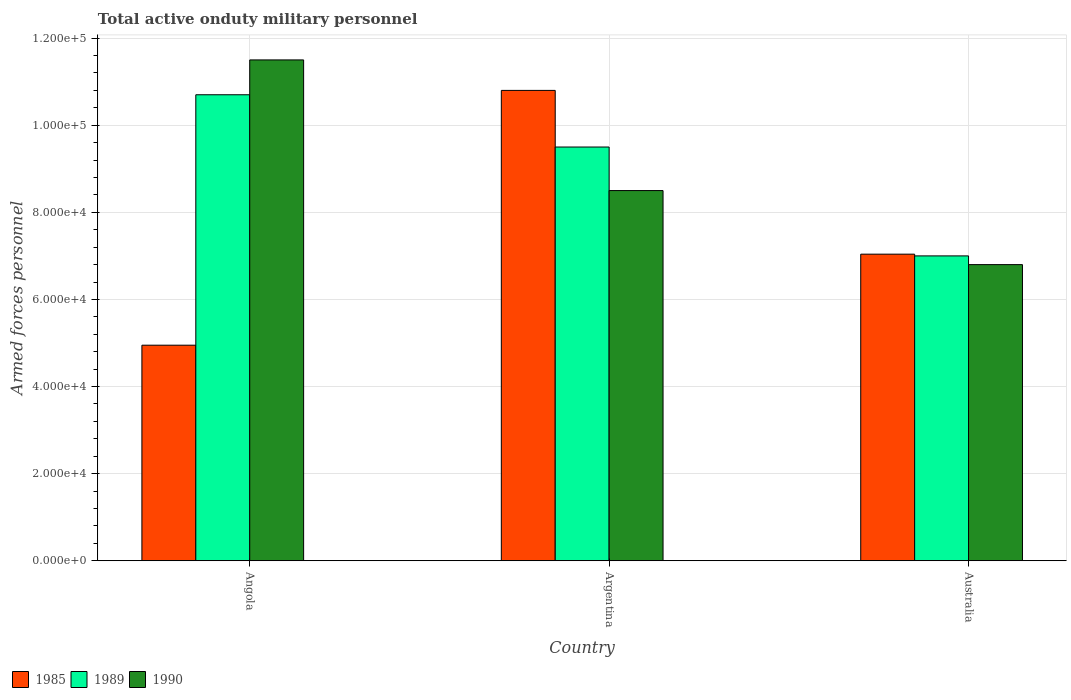How many groups of bars are there?
Provide a short and direct response. 3. Are the number of bars per tick equal to the number of legend labels?
Offer a very short reply. Yes. Are the number of bars on each tick of the X-axis equal?
Ensure brevity in your answer.  Yes. How many bars are there on the 3rd tick from the left?
Your response must be concise. 3. How many bars are there on the 1st tick from the right?
Your response must be concise. 3. What is the label of the 3rd group of bars from the left?
Provide a succinct answer. Australia. In how many cases, is the number of bars for a given country not equal to the number of legend labels?
Your answer should be compact. 0. What is the number of armed forces personnel in 1989 in Argentina?
Make the answer very short. 9.50e+04. Across all countries, what is the maximum number of armed forces personnel in 1989?
Offer a terse response. 1.07e+05. Across all countries, what is the minimum number of armed forces personnel in 1990?
Keep it short and to the point. 6.80e+04. In which country was the number of armed forces personnel in 1985 maximum?
Give a very brief answer. Argentina. What is the total number of armed forces personnel in 1990 in the graph?
Offer a terse response. 2.68e+05. What is the difference between the number of armed forces personnel in 1989 in Argentina and that in Australia?
Make the answer very short. 2.50e+04. What is the difference between the number of armed forces personnel in 1989 in Argentina and the number of armed forces personnel in 1990 in Angola?
Ensure brevity in your answer.  -2.00e+04. What is the average number of armed forces personnel in 1989 per country?
Keep it short and to the point. 9.07e+04. What is the difference between the number of armed forces personnel of/in 1990 and number of armed forces personnel of/in 1989 in Angola?
Offer a terse response. 8000. In how many countries, is the number of armed forces personnel in 1990 greater than 100000?
Make the answer very short. 1. What is the ratio of the number of armed forces personnel in 1990 in Angola to that in Australia?
Provide a succinct answer. 1.69. Is the number of armed forces personnel in 1990 in Angola less than that in Argentina?
Make the answer very short. No. Is the difference between the number of armed forces personnel in 1990 in Angola and Argentina greater than the difference between the number of armed forces personnel in 1989 in Angola and Argentina?
Your response must be concise. Yes. What is the difference between the highest and the second highest number of armed forces personnel in 1989?
Offer a very short reply. 1.20e+04. What is the difference between the highest and the lowest number of armed forces personnel in 1989?
Provide a succinct answer. 3.70e+04. What does the 1st bar from the left in Argentina represents?
Your answer should be very brief. 1985. What does the 1st bar from the right in Angola represents?
Ensure brevity in your answer.  1990. Is it the case that in every country, the sum of the number of armed forces personnel in 1989 and number of armed forces personnel in 1985 is greater than the number of armed forces personnel in 1990?
Keep it short and to the point. Yes. How many bars are there?
Your answer should be very brief. 9. Are all the bars in the graph horizontal?
Ensure brevity in your answer.  No. How many countries are there in the graph?
Provide a short and direct response. 3. Are the values on the major ticks of Y-axis written in scientific E-notation?
Give a very brief answer. Yes. Does the graph contain any zero values?
Provide a short and direct response. No. Where does the legend appear in the graph?
Your answer should be very brief. Bottom left. How are the legend labels stacked?
Offer a terse response. Horizontal. What is the title of the graph?
Provide a succinct answer. Total active onduty military personnel. What is the label or title of the Y-axis?
Provide a succinct answer. Armed forces personnel. What is the Armed forces personnel in 1985 in Angola?
Your answer should be very brief. 4.95e+04. What is the Armed forces personnel of 1989 in Angola?
Your response must be concise. 1.07e+05. What is the Armed forces personnel of 1990 in Angola?
Offer a very short reply. 1.15e+05. What is the Armed forces personnel of 1985 in Argentina?
Your answer should be compact. 1.08e+05. What is the Armed forces personnel of 1989 in Argentina?
Give a very brief answer. 9.50e+04. What is the Armed forces personnel of 1990 in Argentina?
Provide a succinct answer. 8.50e+04. What is the Armed forces personnel of 1985 in Australia?
Your answer should be very brief. 7.04e+04. What is the Armed forces personnel in 1989 in Australia?
Offer a terse response. 7.00e+04. What is the Armed forces personnel of 1990 in Australia?
Provide a short and direct response. 6.80e+04. Across all countries, what is the maximum Armed forces personnel in 1985?
Give a very brief answer. 1.08e+05. Across all countries, what is the maximum Armed forces personnel of 1989?
Give a very brief answer. 1.07e+05. Across all countries, what is the maximum Armed forces personnel in 1990?
Your answer should be very brief. 1.15e+05. Across all countries, what is the minimum Armed forces personnel of 1985?
Your answer should be compact. 4.95e+04. Across all countries, what is the minimum Armed forces personnel of 1989?
Make the answer very short. 7.00e+04. Across all countries, what is the minimum Armed forces personnel in 1990?
Give a very brief answer. 6.80e+04. What is the total Armed forces personnel of 1985 in the graph?
Your answer should be compact. 2.28e+05. What is the total Armed forces personnel in 1989 in the graph?
Offer a very short reply. 2.72e+05. What is the total Armed forces personnel in 1990 in the graph?
Ensure brevity in your answer.  2.68e+05. What is the difference between the Armed forces personnel in 1985 in Angola and that in Argentina?
Your response must be concise. -5.85e+04. What is the difference between the Armed forces personnel of 1989 in Angola and that in Argentina?
Provide a short and direct response. 1.20e+04. What is the difference between the Armed forces personnel in 1985 in Angola and that in Australia?
Offer a very short reply. -2.09e+04. What is the difference between the Armed forces personnel of 1989 in Angola and that in Australia?
Give a very brief answer. 3.70e+04. What is the difference between the Armed forces personnel of 1990 in Angola and that in Australia?
Your answer should be very brief. 4.70e+04. What is the difference between the Armed forces personnel of 1985 in Argentina and that in Australia?
Offer a very short reply. 3.76e+04. What is the difference between the Armed forces personnel of 1989 in Argentina and that in Australia?
Make the answer very short. 2.50e+04. What is the difference between the Armed forces personnel of 1990 in Argentina and that in Australia?
Your answer should be compact. 1.70e+04. What is the difference between the Armed forces personnel in 1985 in Angola and the Armed forces personnel in 1989 in Argentina?
Offer a very short reply. -4.55e+04. What is the difference between the Armed forces personnel in 1985 in Angola and the Armed forces personnel in 1990 in Argentina?
Offer a terse response. -3.55e+04. What is the difference between the Armed forces personnel in 1989 in Angola and the Armed forces personnel in 1990 in Argentina?
Keep it short and to the point. 2.20e+04. What is the difference between the Armed forces personnel of 1985 in Angola and the Armed forces personnel of 1989 in Australia?
Ensure brevity in your answer.  -2.05e+04. What is the difference between the Armed forces personnel of 1985 in Angola and the Armed forces personnel of 1990 in Australia?
Offer a terse response. -1.85e+04. What is the difference between the Armed forces personnel in 1989 in Angola and the Armed forces personnel in 1990 in Australia?
Offer a terse response. 3.90e+04. What is the difference between the Armed forces personnel in 1985 in Argentina and the Armed forces personnel in 1989 in Australia?
Your response must be concise. 3.80e+04. What is the difference between the Armed forces personnel of 1985 in Argentina and the Armed forces personnel of 1990 in Australia?
Your answer should be compact. 4.00e+04. What is the difference between the Armed forces personnel of 1989 in Argentina and the Armed forces personnel of 1990 in Australia?
Provide a succinct answer. 2.70e+04. What is the average Armed forces personnel in 1985 per country?
Ensure brevity in your answer.  7.60e+04. What is the average Armed forces personnel in 1989 per country?
Provide a short and direct response. 9.07e+04. What is the average Armed forces personnel of 1990 per country?
Make the answer very short. 8.93e+04. What is the difference between the Armed forces personnel in 1985 and Armed forces personnel in 1989 in Angola?
Offer a terse response. -5.75e+04. What is the difference between the Armed forces personnel of 1985 and Armed forces personnel of 1990 in Angola?
Ensure brevity in your answer.  -6.55e+04. What is the difference between the Armed forces personnel of 1989 and Armed forces personnel of 1990 in Angola?
Provide a succinct answer. -8000. What is the difference between the Armed forces personnel of 1985 and Armed forces personnel of 1989 in Argentina?
Your answer should be very brief. 1.30e+04. What is the difference between the Armed forces personnel of 1985 and Armed forces personnel of 1990 in Argentina?
Make the answer very short. 2.30e+04. What is the difference between the Armed forces personnel in 1985 and Armed forces personnel in 1989 in Australia?
Your answer should be compact. 400. What is the difference between the Armed forces personnel in 1985 and Armed forces personnel in 1990 in Australia?
Your answer should be very brief. 2400. What is the difference between the Armed forces personnel of 1989 and Armed forces personnel of 1990 in Australia?
Make the answer very short. 2000. What is the ratio of the Armed forces personnel in 1985 in Angola to that in Argentina?
Your answer should be compact. 0.46. What is the ratio of the Armed forces personnel in 1989 in Angola to that in Argentina?
Offer a terse response. 1.13. What is the ratio of the Armed forces personnel in 1990 in Angola to that in Argentina?
Ensure brevity in your answer.  1.35. What is the ratio of the Armed forces personnel in 1985 in Angola to that in Australia?
Make the answer very short. 0.7. What is the ratio of the Armed forces personnel of 1989 in Angola to that in Australia?
Keep it short and to the point. 1.53. What is the ratio of the Armed forces personnel of 1990 in Angola to that in Australia?
Provide a short and direct response. 1.69. What is the ratio of the Armed forces personnel of 1985 in Argentina to that in Australia?
Make the answer very short. 1.53. What is the ratio of the Armed forces personnel in 1989 in Argentina to that in Australia?
Your answer should be very brief. 1.36. What is the ratio of the Armed forces personnel of 1990 in Argentina to that in Australia?
Ensure brevity in your answer.  1.25. What is the difference between the highest and the second highest Armed forces personnel of 1985?
Your answer should be compact. 3.76e+04. What is the difference between the highest and the second highest Armed forces personnel of 1989?
Keep it short and to the point. 1.20e+04. What is the difference between the highest and the second highest Armed forces personnel in 1990?
Provide a succinct answer. 3.00e+04. What is the difference between the highest and the lowest Armed forces personnel in 1985?
Provide a short and direct response. 5.85e+04. What is the difference between the highest and the lowest Armed forces personnel in 1989?
Your answer should be very brief. 3.70e+04. What is the difference between the highest and the lowest Armed forces personnel in 1990?
Make the answer very short. 4.70e+04. 